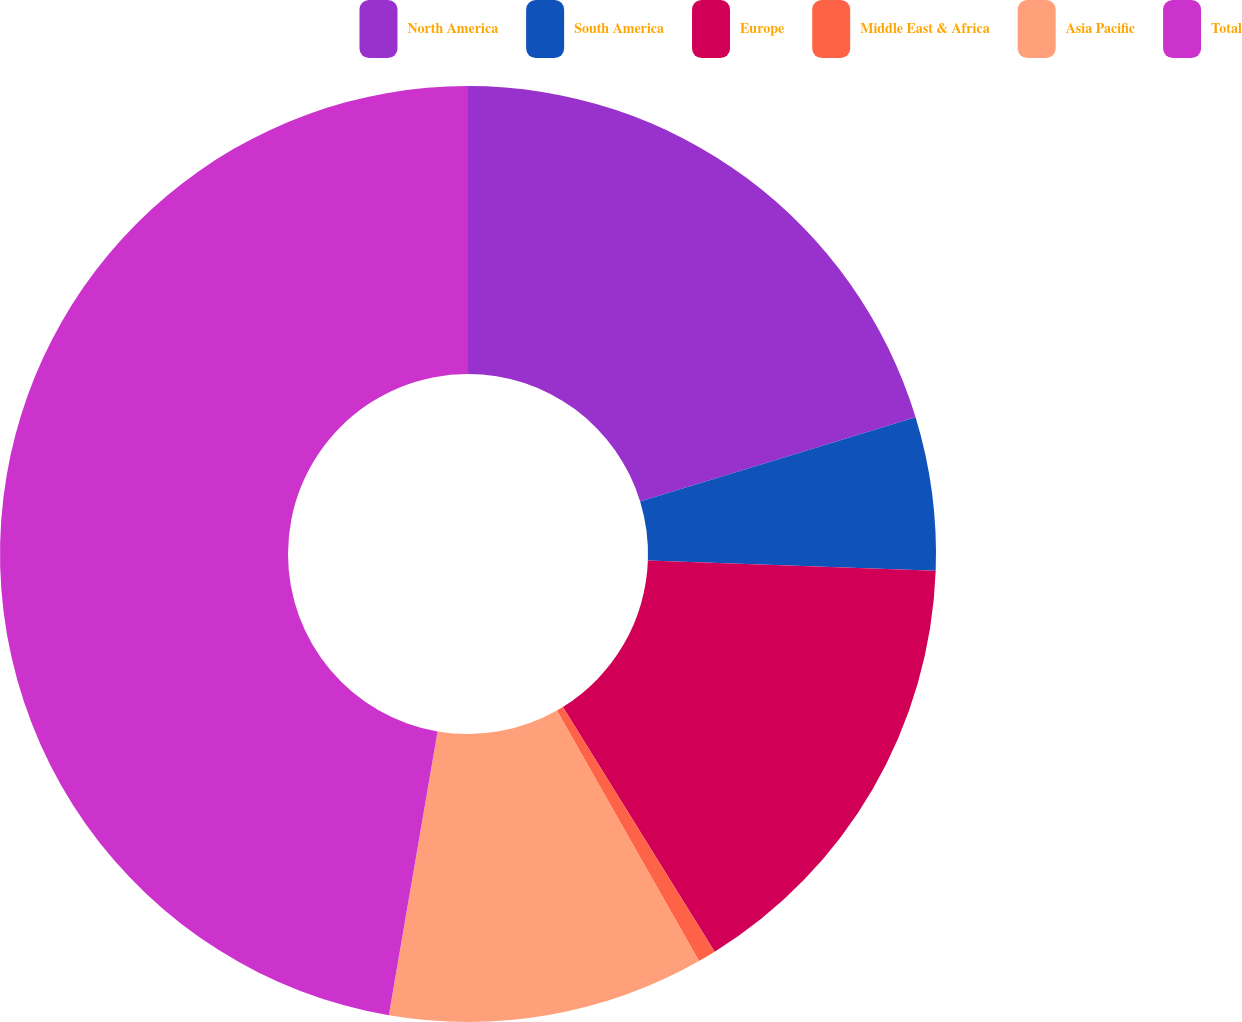<chart> <loc_0><loc_0><loc_500><loc_500><pie_chart><fcel>North America<fcel>South America<fcel>Europe<fcel>Middle East & Africa<fcel>Asia Pacific<fcel>Total<nl><fcel>20.28%<fcel>5.29%<fcel>15.59%<fcel>0.62%<fcel>10.92%<fcel>47.29%<nl></chart> 